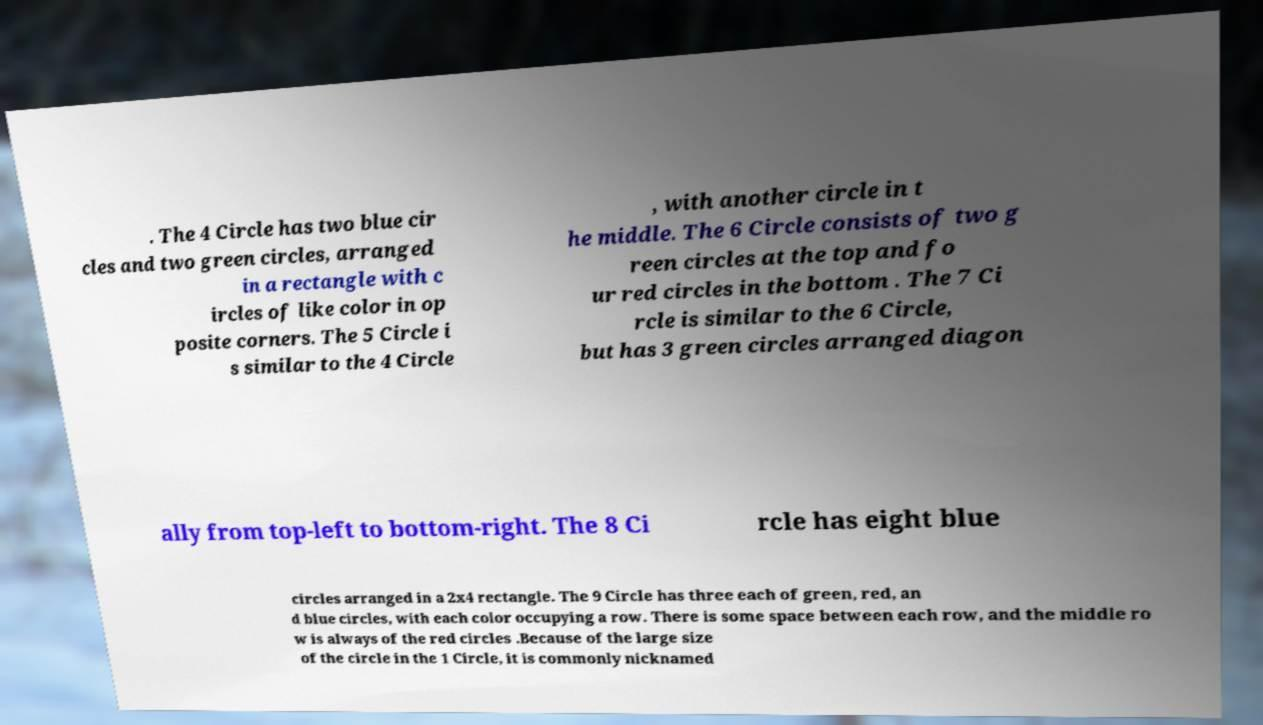There's text embedded in this image that I need extracted. Can you transcribe it verbatim? . The 4 Circle has two blue cir cles and two green circles, arranged in a rectangle with c ircles of like color in op posite corners. The 5 Circle i s similar to the 4 Circle , with another circle in t he middle. The 6 Circle consists of two g reen circles at the top and fo ur red circles in the bottom . The 7 Ci rcle is similar to the 6 Circle, but has 3 green circles arranged diagon ally from top-left to bottom-right. The 8 Ci rcle has eight blue circles arranged in a 2x4 rectangle. The 9 Circle has three each of green, red, an d blue circles, with each color occupying a row. There is some space between each row, and the middle ro w is always of the red circles .Because of the large size of the circle in the 1 Circle, it is commonly nicknamed 